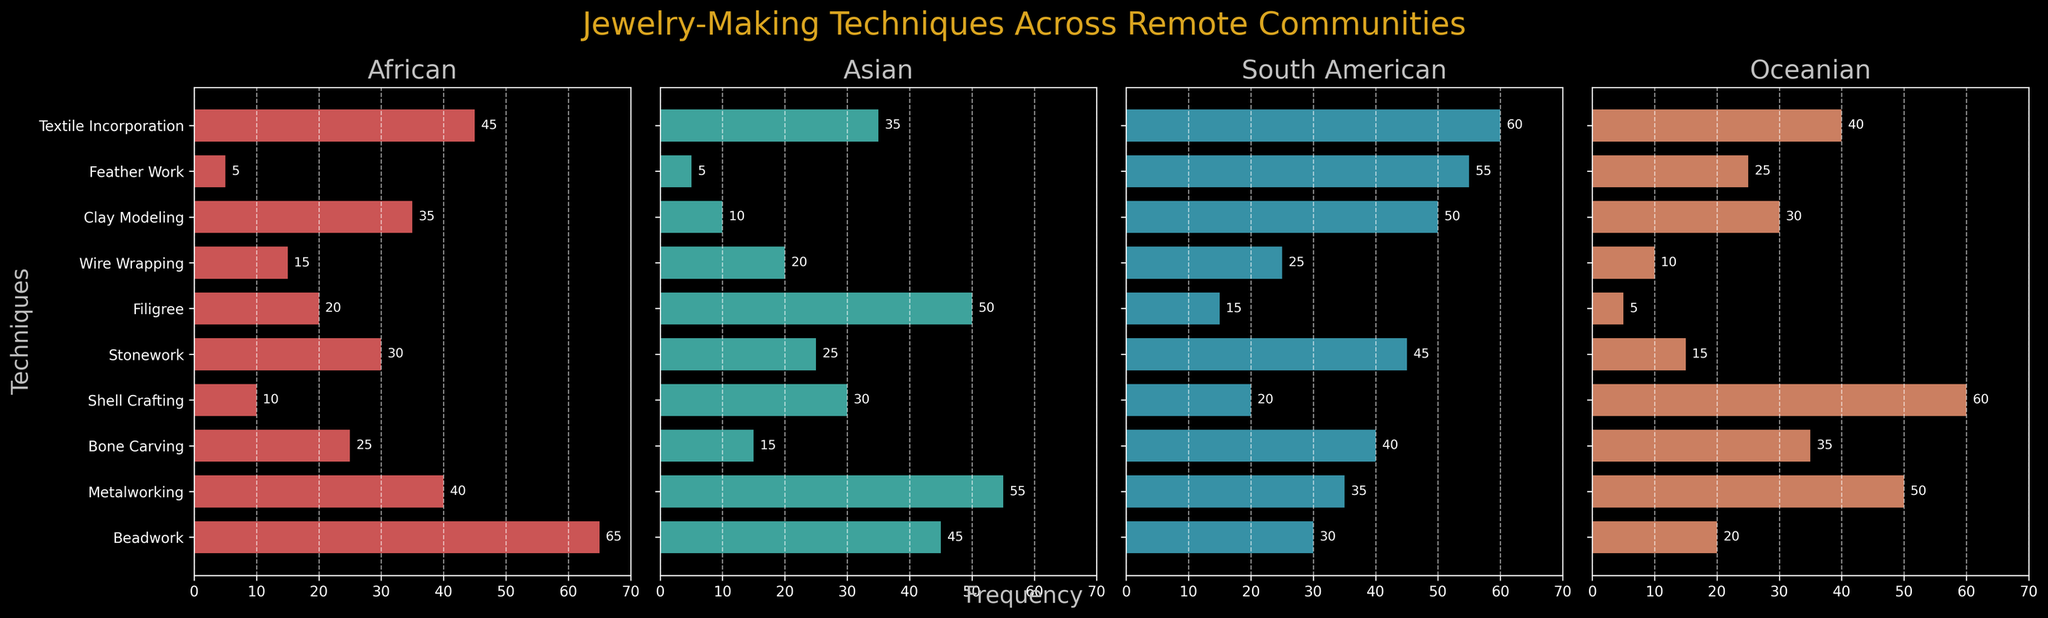Which jewelry-making technique is most frequent in African communities? Beadwork has the highest frequency bar in the African subplot.
Answer: Beadwork Which region has the lowest frequency for Bone Carving? Bone Carving has the lowest bar height in the Asian subplot compared to other regions.
Answer: Asian What is the combined frequency of Metalworking in African and Oceanian communities? Add the frequency from African (40) and Oceanian (50): 40 + 50 = 90.
Answer: 90 Which region shows the highest frequency for Shell Crafting? The highest bar for Shell Crafting is in the Oceanian subplot.
Answer: Oceanian How does the frequency of Feather Work in South American communities compare to African communities? The frequency of Feather Work in South American (55) is higher than in African (5).
Answer: South American has higher frequency What is the average frequency of Filigree across all regions? Sum the frequencies of Filigree across regions (20 + 50 + 15 + 5) and divide by 4: (20 + 50 + 15 + 5) / 4 = 22.5.
Answer: 22.5 Compare the frequency of Textile Incorporation in African and South American communities. Which one is higher by how much? South American (60) has a higher frequency than African (45). The difference is 60 - 45 = 15.
Answer: South American by 15 What is the total frequency of Clay Modeling in all regions? Sum the frequencies of Clay Modeling across regions: 35 + 10 + 50 + 30 = 125.
Answer: 125 Which technique has the highest variability in frequency values across regions? By comparing the difference between maximum and minimum values for each technique across regions, Feather Work (55-5=50) shows the highest variability.
Answer: Feather Work What is the least common technique in the Asian region? Feather Work and Clay Modeling both have the shortest bar (5) in the Asian subplot, making them the least common.
Answer: Feather Work and Clay Modeling 